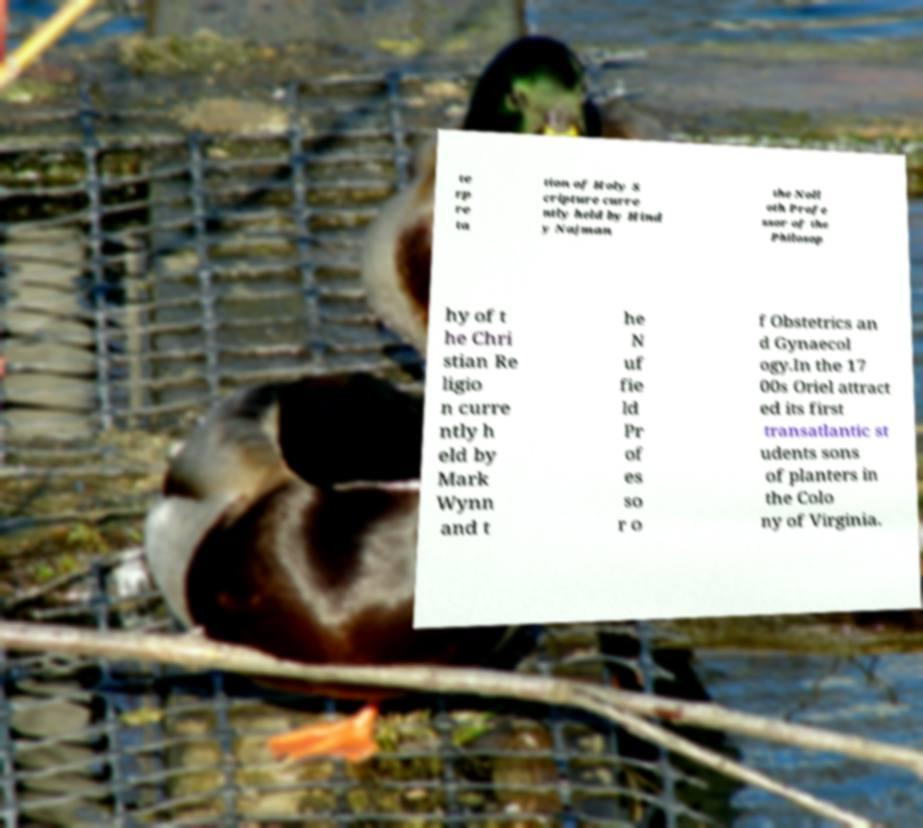Could you assist in decoding the text presented in this image and type it out clearly? te rp re ta tion of Holy S cripture curre ntly held by Hind y Najman the Noll oth Profe ssor of the Philosop hy of t he Chri stian Re ligio n curre ntly h eld by Mark Wynn and t he N uf fie ld Pr of es so r o f Obstetrics an d Gynaecol ogy.In the 17 00s Oriel attract ed its first transatlantic st udents sons of planters in the Colo ny of Virginia. 